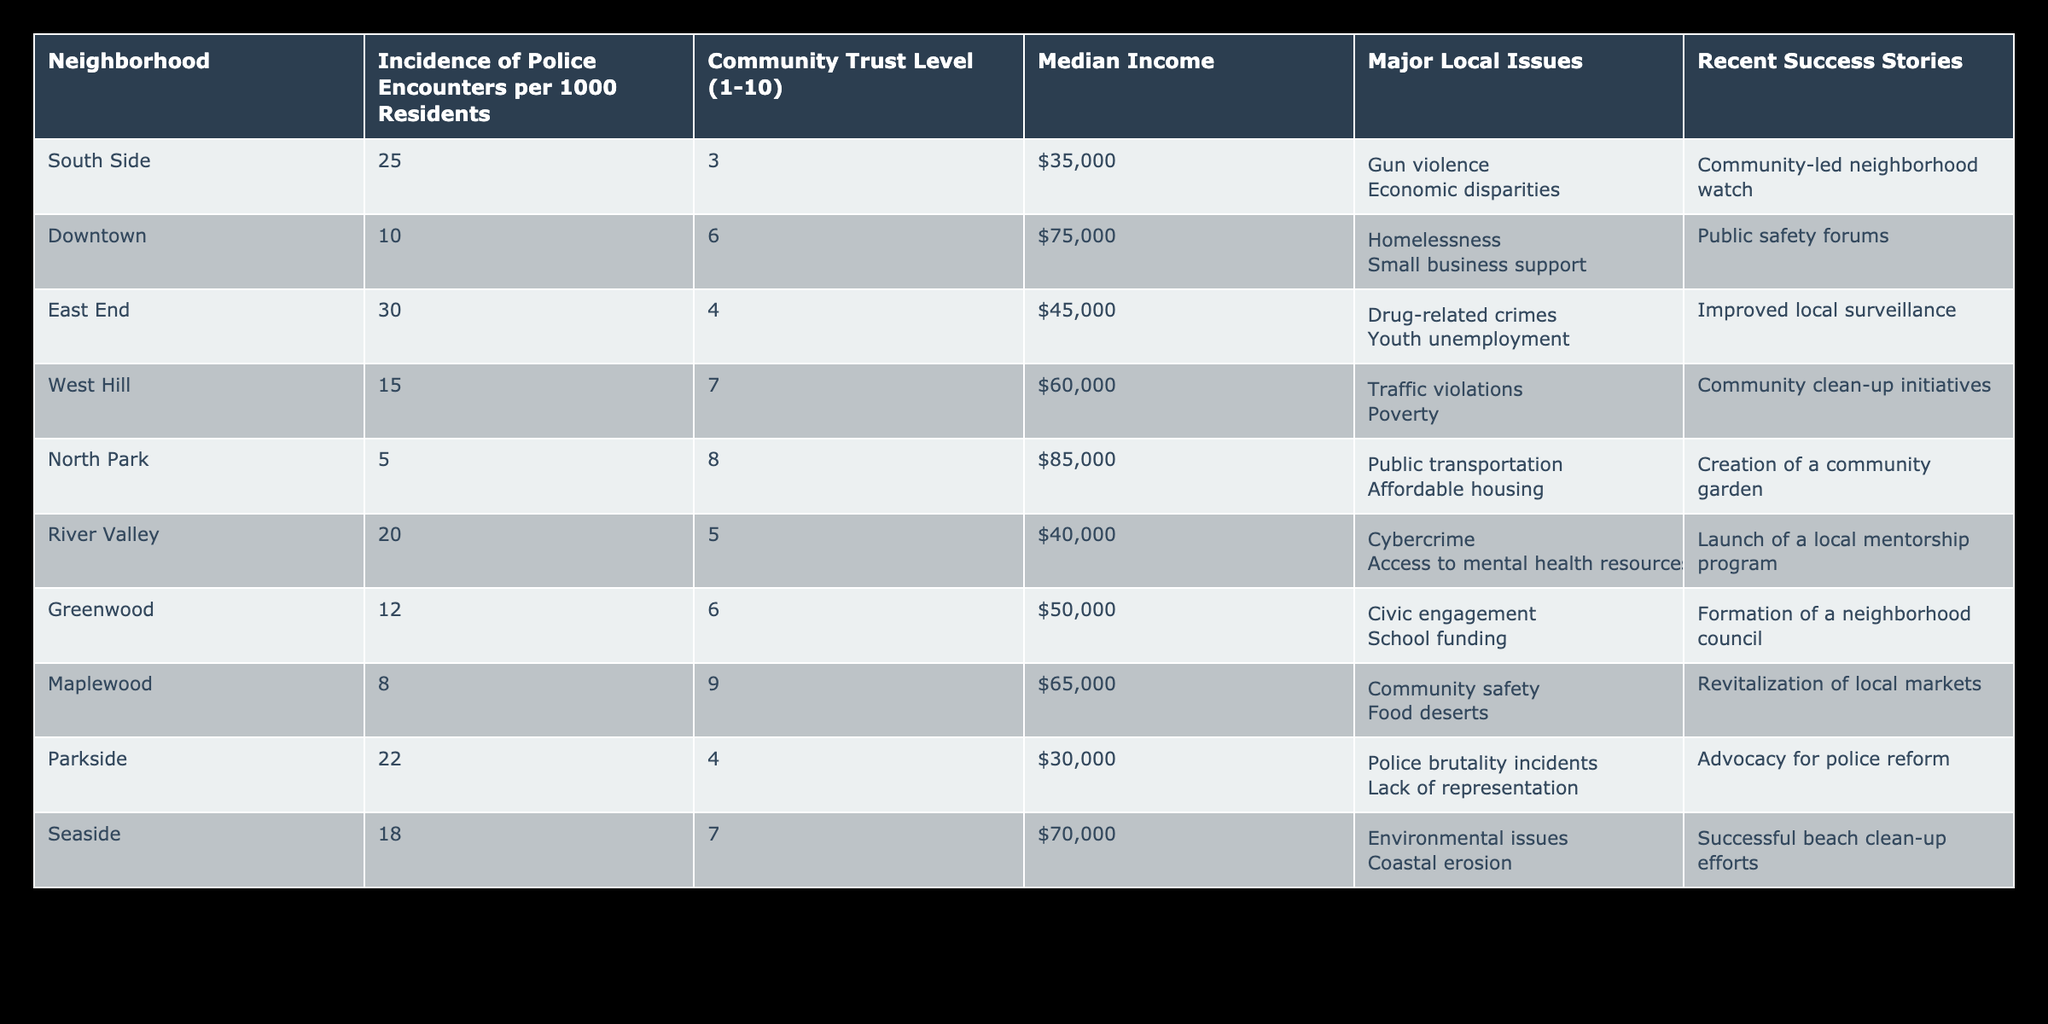What is the community trust level in the South Side? The table shows that the community trust level for the South Side is 3, as indicated in the relevant row.
Answer: 3 Which neighborhood has the highest incidence of police encounters? By scanning the table, I find that the East End has the highest incidence of police encounters at 30 per 1000 residents, which is the highest figure in that column.
Answer: 30 What is the median income of North Park? According to the table, North Park has a median income of $85,000, which is the figure listed in the Median Income column for that neighborhood.
Answer: $85,000 Is there a neighborhood with a community trust level of 9? The table indicates that Maplewood has a community trust level of 9; therefore, the statement is true.
Answer: Yes What issues are common in higher crime neighborhoods, such as East End and South Side? Both East End (30 police encounters) and South Side (25 police encounters) list issues like drug-related crimes and gun violence, respectively, both linked to systemic issues that impact community safety and trust.
Answer: Gun violence and drug-related crimes What is the difference in community trust levels between Downtown and Parkside? The community trust level for Downtown is 6, while for Parkside, it is 4. The difference is calculated as 6 - 4 = 2.
Answer: 2 Which neighborhood has a recent success story of a community-led neighborhood watch? The table indicates that the South Side has a recent success story of a community-led neighborhood watch, which is mentioned in the Recent Success Stories column.
Answer: South Side What is the average incidence of police encounters for neighborhoods with a community trust level of 5 or less? The neighborhoods that fit this criterion are South Side (25), East End (30), Parkside (22), and River Valley (20). The average is calculated as (25 + 30 + 22 + 20) / 4 = 24.25.
Answer: 24.25 How many neighborhoods have a median income below $50,000, and what are their names? By reviewing the Median Income column, I find that South Side ($35,000), East End ($45,000), and River Valley ($40,000) are below $50,000, totaling three neighborhoods: South Side, East End, and River Valley.
Answer: 3 (South Side, East End, River Valley) 